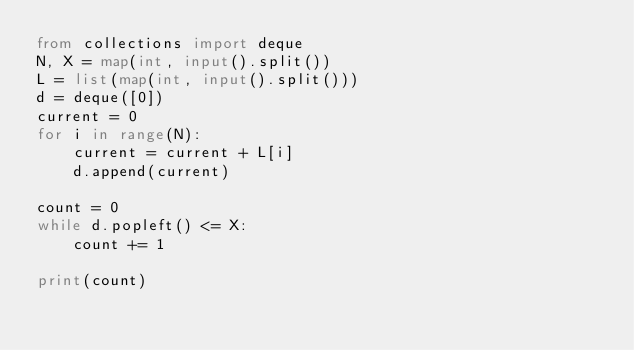Convert code to text. <code><loc_0><loc_0><loc_500><loc_500><_Python_>from collections import deque
N, X = map(int, input().split())
L = list(map(int, input().split()))
d = deque([0])
current = 0
for i in range(N):
    current = current + L[i]
    d.append(current)

count = 0
while d.popleft() <= X:
    count += 1

print(count)
</code> 